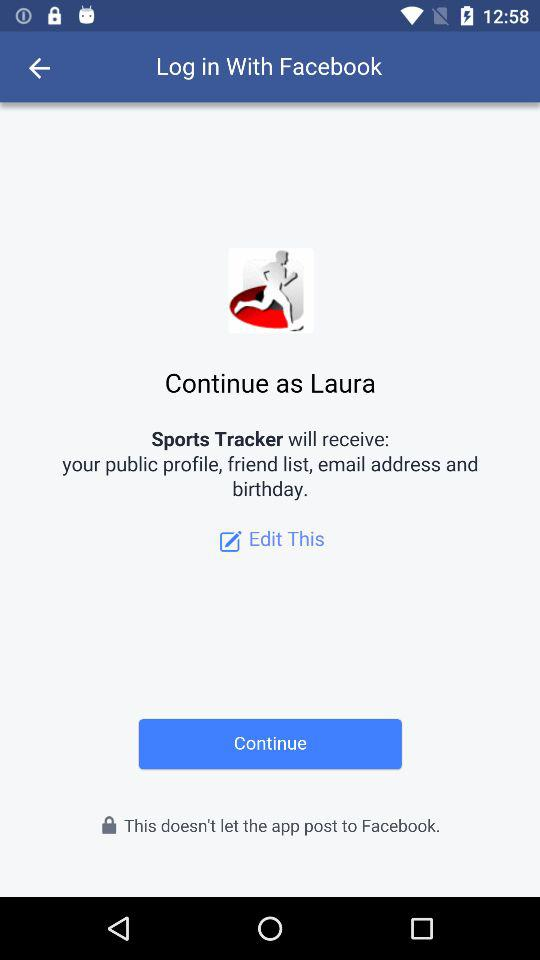When is the user's birthday?
When the provided information is insufficient, respond with <no answer>. <no answer> 